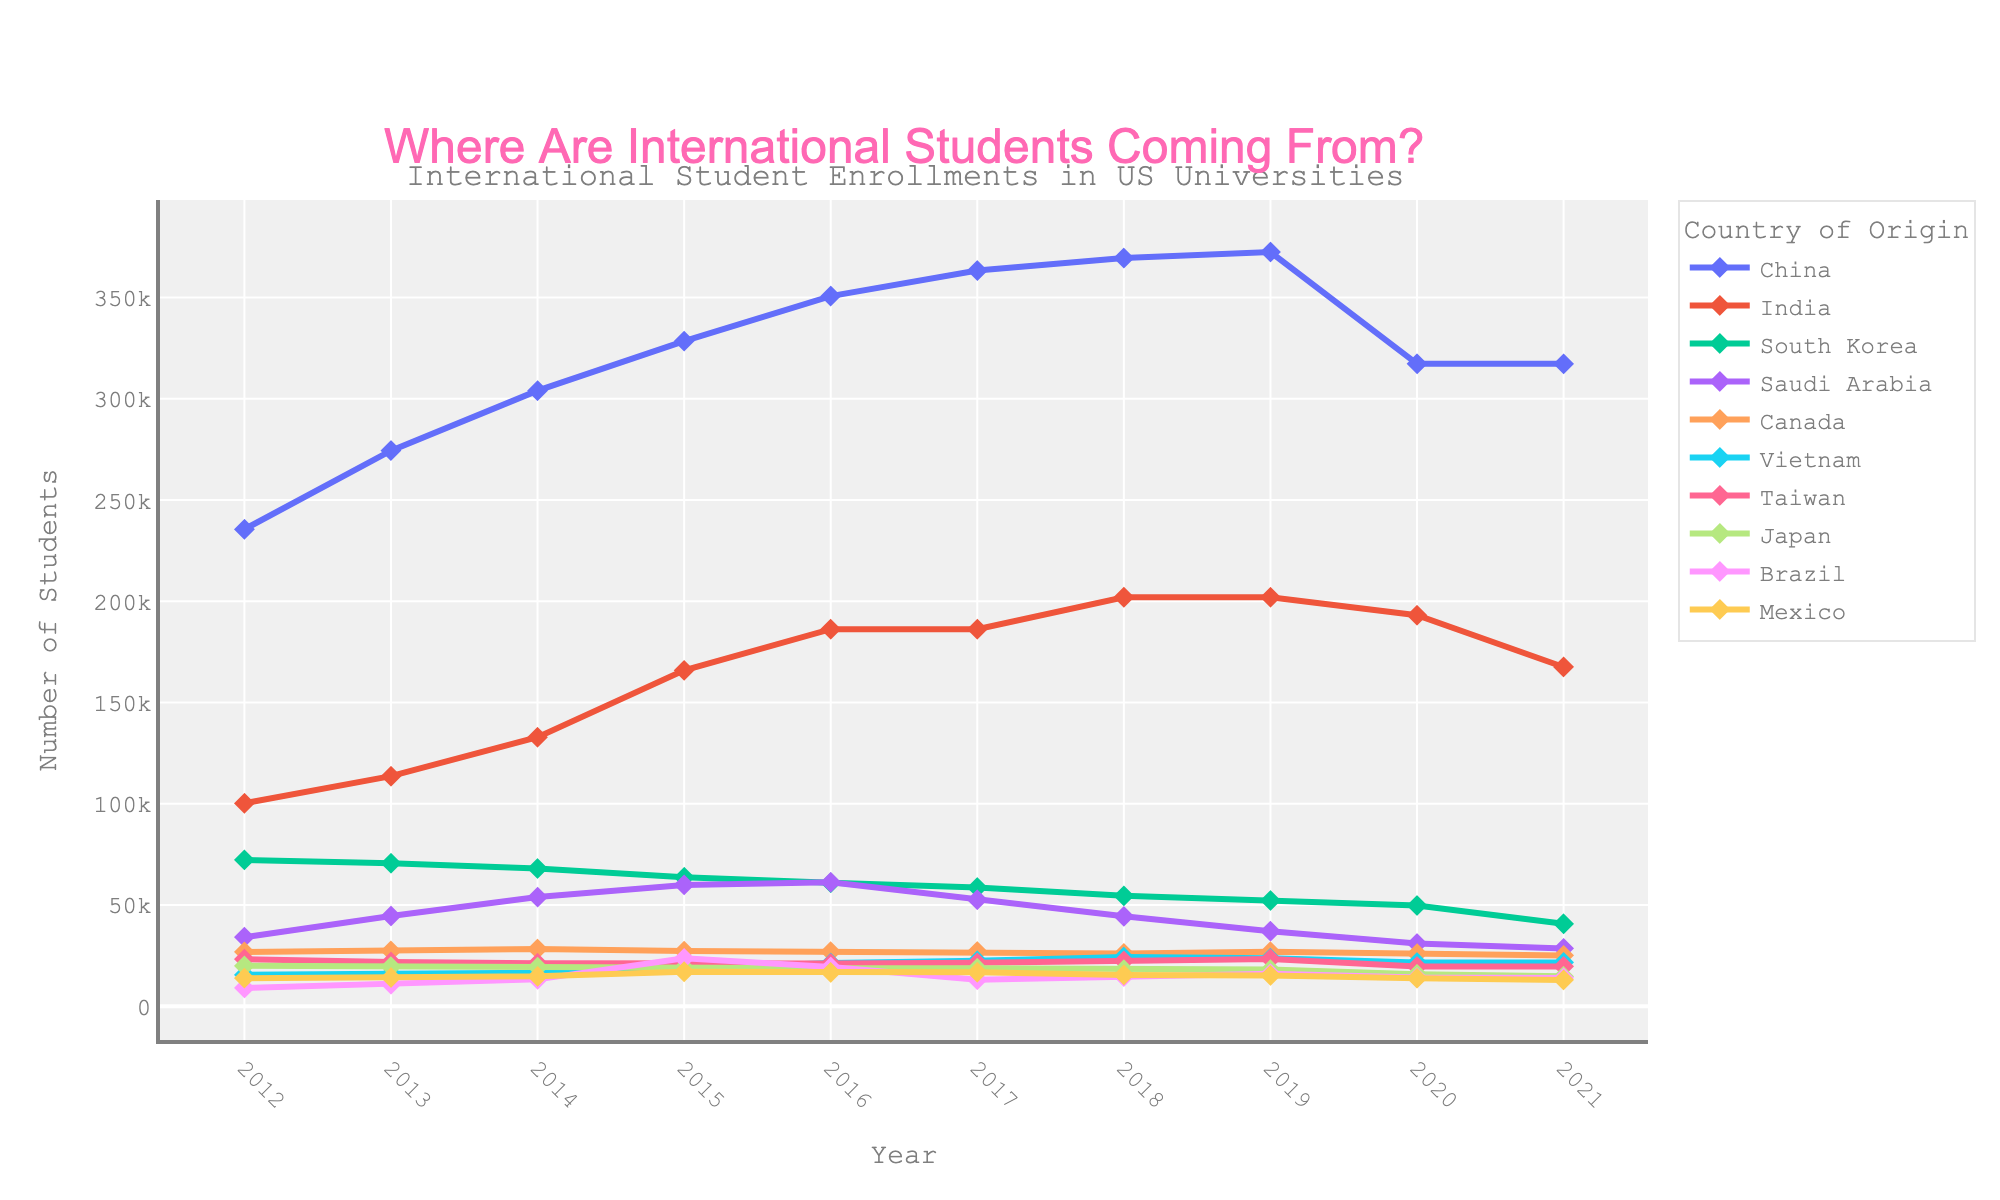What was the trend for Chinese student enrollments between 2014 and 2017? Observing the line for China, the enrollment numbers increased from 304,040 in 2014 to 363,341 in 2017. This shows a rising trend.
Answer: Increasing Which country had the largest drop in student enrollments from 2019 to 2020? By comparing the changes in values between 2019 and 2020 for each country, India had the largest drop from 202,014 to 193,124, a decrease of 8,890 students.
Answer: India What is the difference in student enrollments between South Korea and Vietnam in 2021? In 2021, South Korea had 40,755 enrollments and Vietnam had 21,631 enrollments. The difference is 40,755 - 21,631 = 19,124.
Answer: 19,124 Which country had the highest number of international student enrollments in 2021? Looking at the 2021 column, China had the highest number with 317,299 enrollments.
Answer: China By how much did Saudi Arabian student enrollments decrease from their peak in 2016? Saudi Arabian enrollments peaked at 61,287 in 2016 and decreased to 28,600 in 2021. The decrease is 61,287 - 28,600 = 32,687.
Answer: 32,687 Which country had consistently increasing enrollments from 2012 to 2018? Vietnam shows a consistent increase from 15,572 in 2012 to 24,325 in 2018.
Answer: Vietnam What is the average number of enrollments for Brazilian students from 2014 to 2018? The enrollments for Brazil from 2014 to 2018 are 13,286, 23,675, 19,370, 13,089, and 14,620. The sum is 83,040, thus the average is 83,040 / 5 = 16,608.
Answer: 16,608 How does the enrollment trend for Canadian students compare from 2012 to 2021? Examining the data, Canadian enrollment figures remained relatively stable from 26,821 in 2012 to 25,143 in 2021 with minor fluctuations.
Answer: Stable Which country's enrollment trend shows a peak followed by a steady decline after 2015? South Korea's enrollments peaked at 72,295 in 2012 and have been steadily declining each year, ending at 40,755 in 2021.
Answer: South Korea 